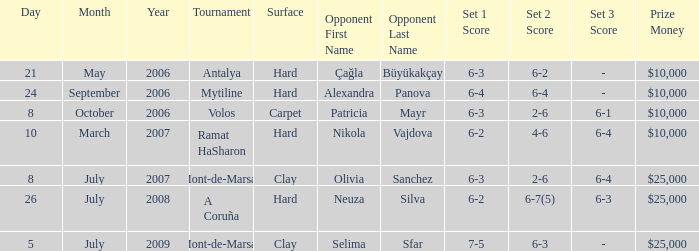What is the surface for the Volos tournament? Carpet. 